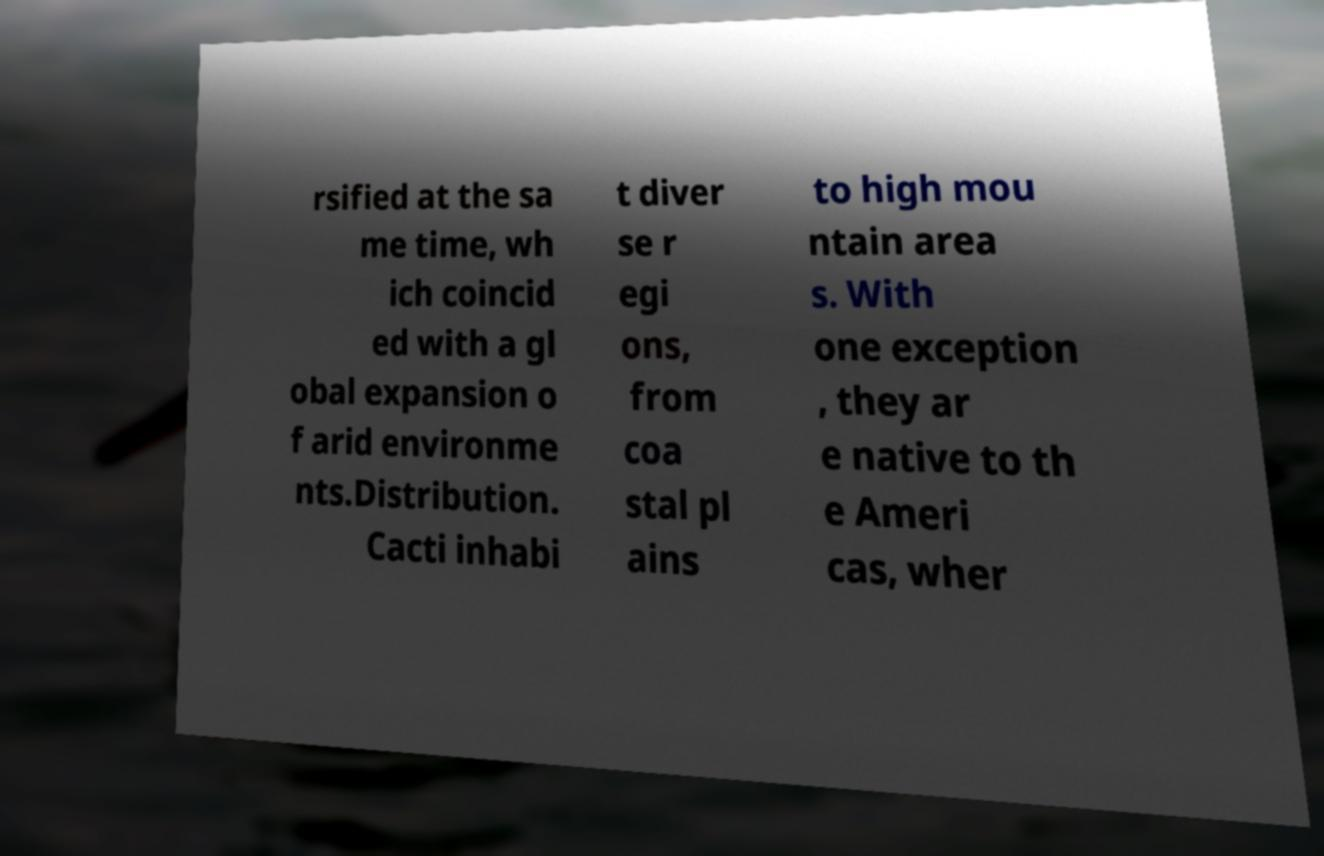I need the written content from this picture converted into text. Can you do that? rsified at the sa me time, wh ich coincid ed with a gl obal expansion o f arid environme nts.Distribution. Cacti inhabi t diver se r egi ons, from coa stal pl ains to high mou ntain area s. With one exception , they ar e native to th e Ameri cas, wher 